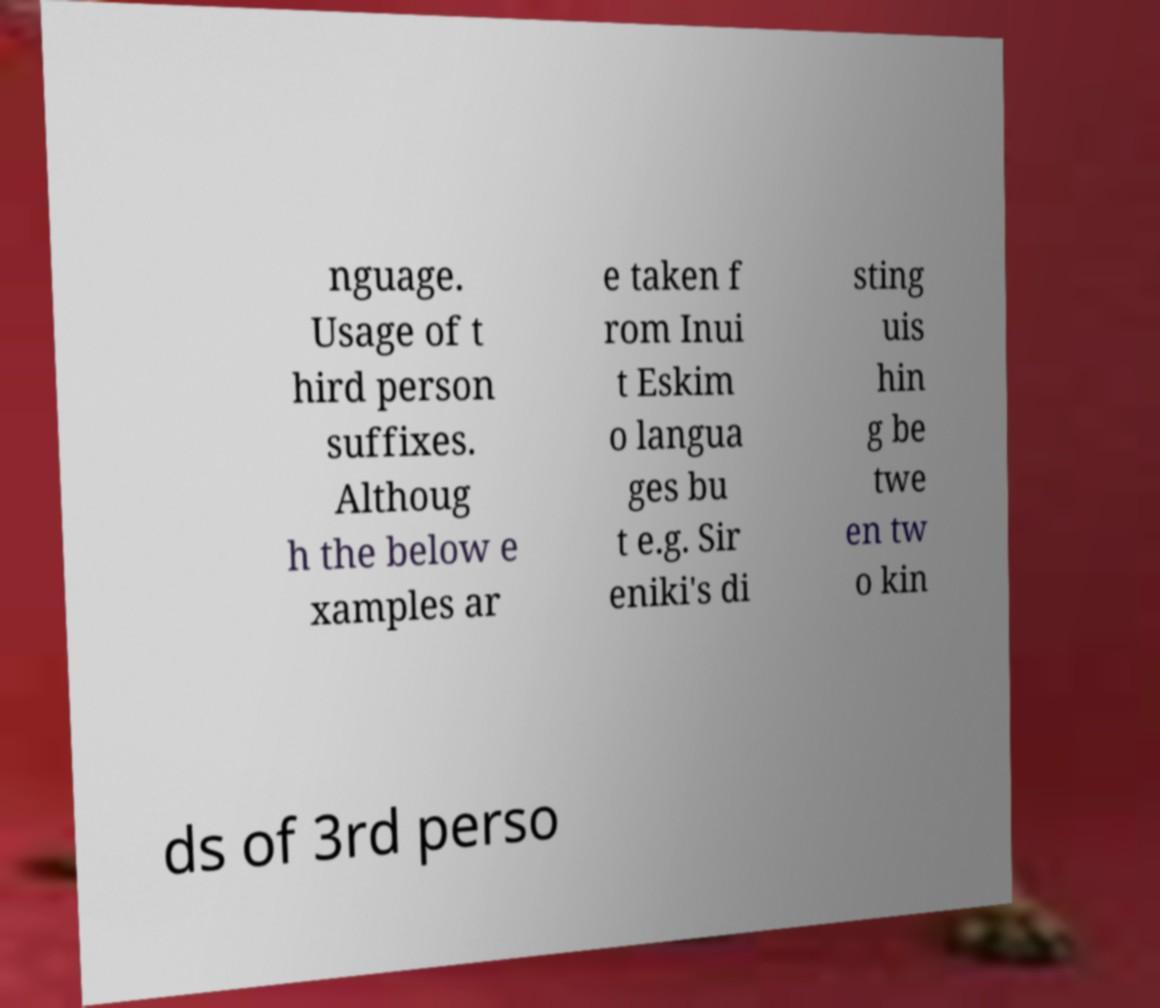For documentation purposes, I need the text within this image transcribed. Could you provide that? nguage. Usage of t hird person suffixes. Althoug h the below e xamples ar e taken f rom Inui t Eskim o langua ges bu t e.g. Sir eniki's di sting uis hin g be twe en tw o kin ds of 3rd perso 